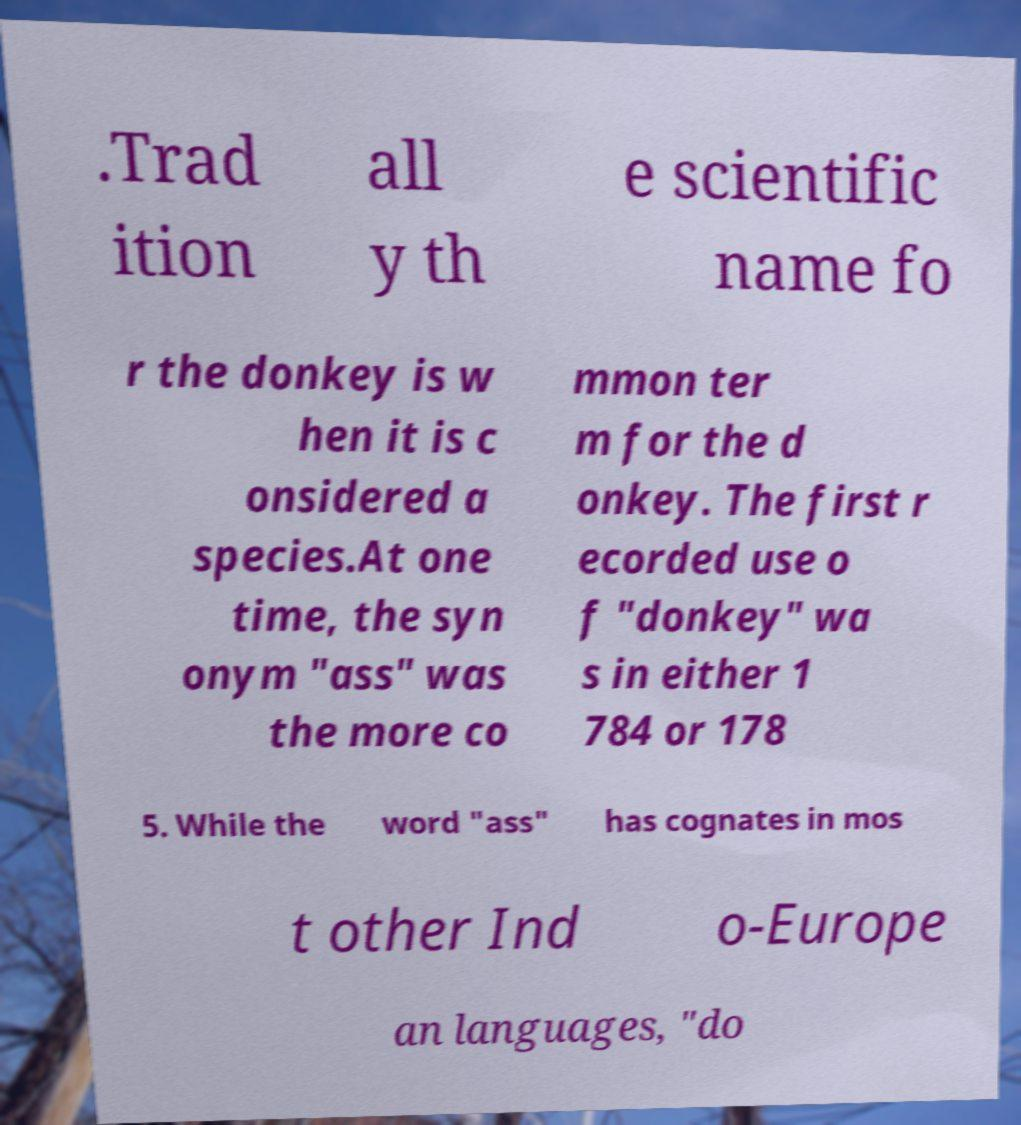Can you accurately transcribe the text from the provided image for me? .Trad ition all y th e scientific name fo r the donkey is w hen it is c onsidered a species.At one time, the syn onym "ass" was the more co mmon ter m for the d onkey. The first r ecorded use o f "donkey" wa s in either 1 784 or 178 5. While the word "ass" has cognates in mos t other Ind o-Europe an languages, "do 